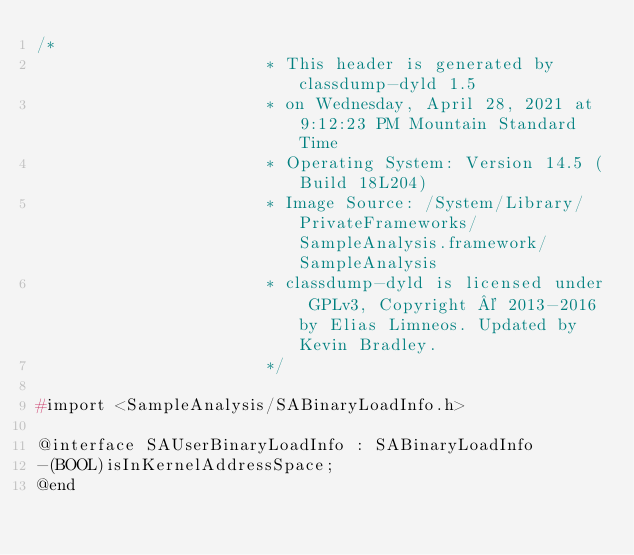<code> <loc_0><loc_0><loc_500><loc_500><_C_>/*
                       * This header is generated by classdump-dyld 1.5
                       * on Wednesday, April 28, 2021 at 9:12:23 PM Mountain Standard Time
                       * Operating System: Version 14.5 (Build 18L204)
                       * Image Source: /System/Library/PrivateFrameworks/SampleAnalysis.framework/SampleAnalysis
                       * classdump-dyld is licensed under GPLv3, Copyright © 2013-2016 by Elias Limneos. Updated by Kevin Bradley.
                       */

#import <SampleAnalysis/SABinaryLoadInfo.h>

@interface SAUserBinaryLoadInfo : SABinaryLoadInfo
-(BOOL)isInKernelAddressSpace;
@end

</code> 